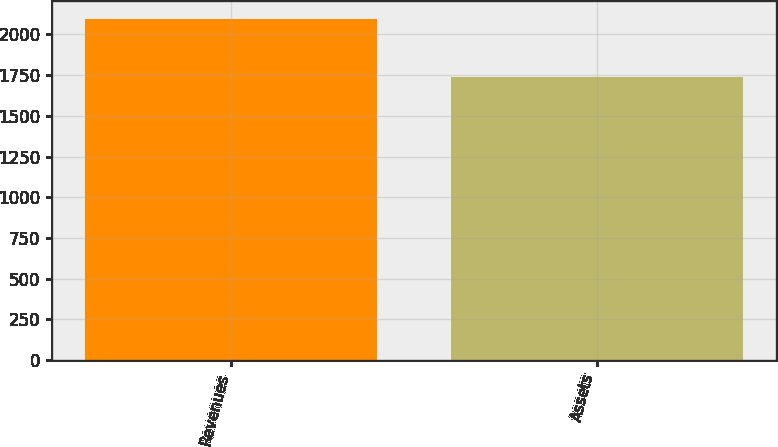Convert chart. <chart><loc_0><loc_0><loc_500><loc_500><bar_chart><fcel>Revenues<fcel>Assets<nl><fcel>2097.9<fcel>1739.5<nl></chart> 